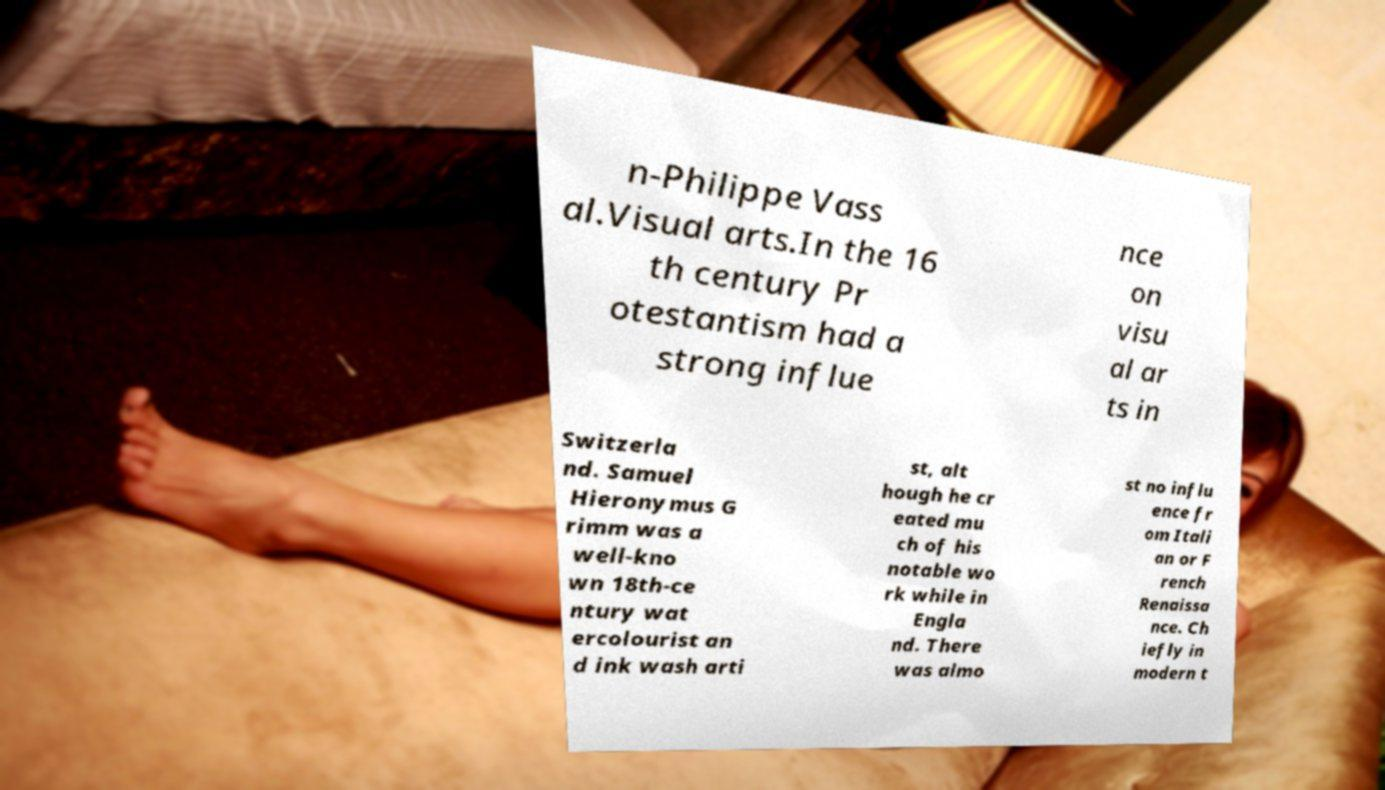What messages or text are displayed in this image? I need them in a readable, typed format. n-Philippe Vass al.Visual arts.In the 16 th century Pr otestantism had a strong influe nce on visu al ar ts in Switzerla nd. Samuel Hieronymus G rimm was a well-kno wn 18th-ce ntury wat ercolourist an d ink wash arti st, alt hough he cr eated mu ch of his notable wo rk while in Engla nd. There was almo st no influ ence fr om Itali an or F rench Renaissa nce. Ch iefly in modern t 